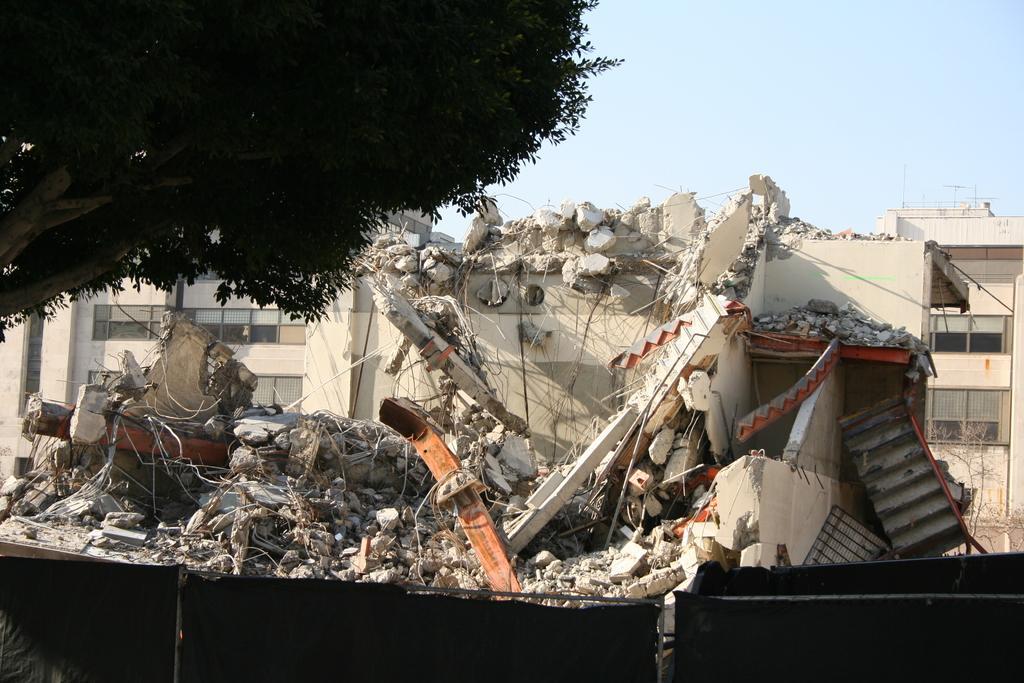Please provide a concise description of this image. In this image there is a collapsed building and beside that there is a tree. 